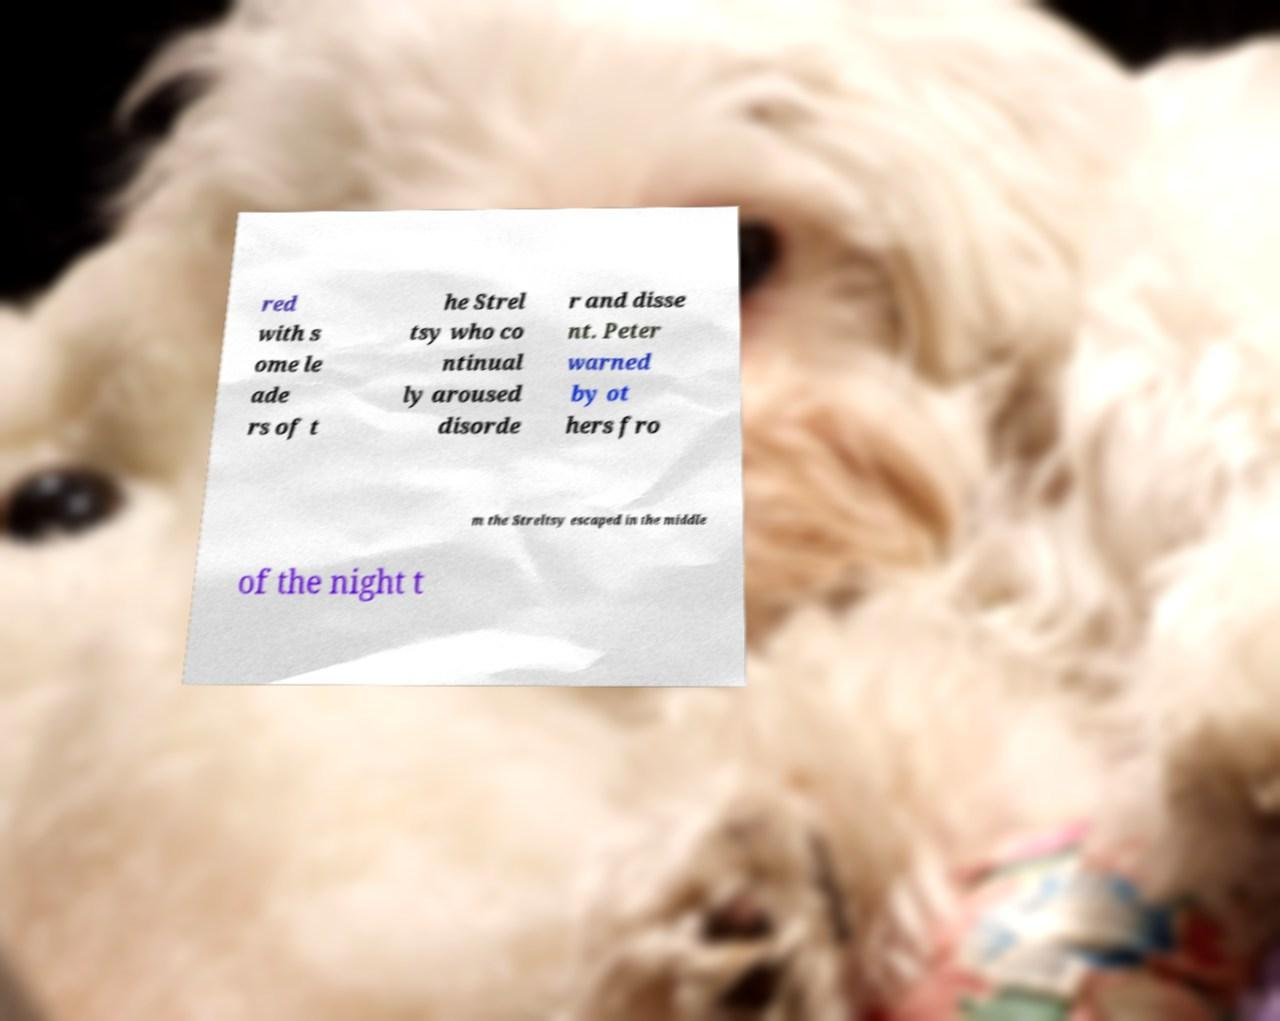Please identify and transcribe the text found in this image. red with s ome le ade rs of t he Strel tsy who co ntinual ly aroused disorde r and disse nt. Peter warned by ot hers fro m the Streltsy escaped in the middle of the night t 